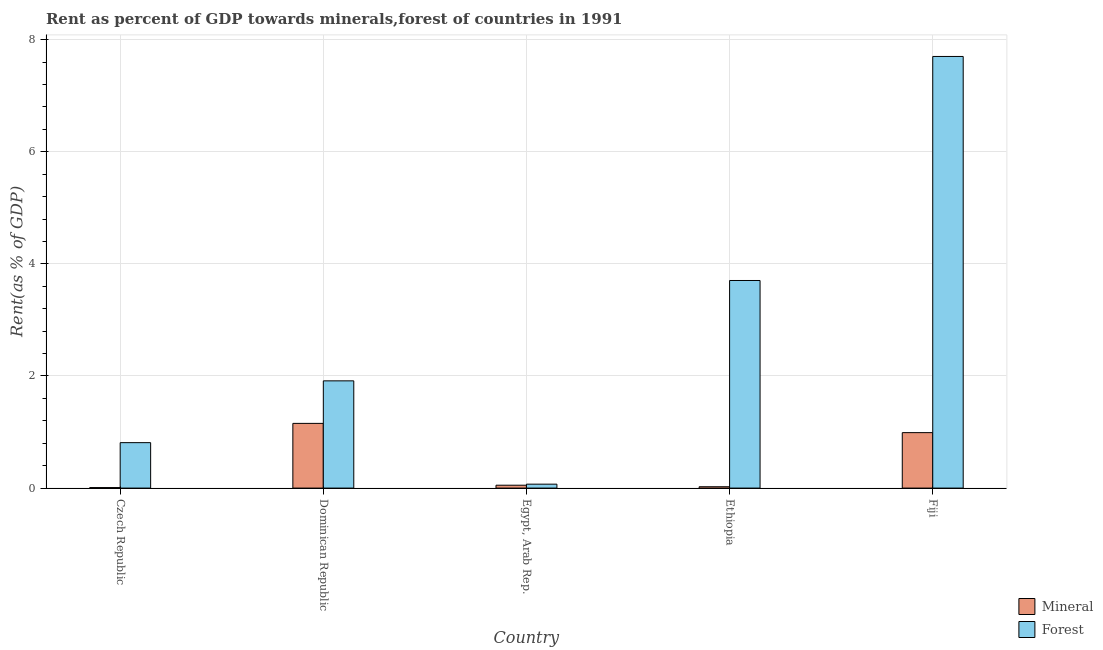Are the number of bars per tick equal to the number of legend labels?
Keep it short and to the point. Yes. Are the number of bars on each tick of the X-axis equal?
Give a very brief answer. Yes. What is the label of the 5th group of bars from the left?
Your answer should be compact. Fiji. What is the mineral rent in Ethiopia?
Your answer should be compact. 0.02. Across all countries, what is the maximum mineral rent?
Offer a terse response. 1.15. Across all countries, what is the minimum forest rent?
Your answer should be very brief. 0.07. In which country was the mineral rent maximum?
Your answer should be compact. Dominican Republic. In which country was the mineral rent minimum?
Ensure brevity in your answer.  Czech Republic. What is the total forest rent in the graph?
Keep it short and to the point. 14.2. What is the difference between the mineral rent in Dominican Republic and that in Egypt, Arab Rep.?
Ensure brevity in your answer.  1.1. What is the difference between the forest rent in Ethiopia and the mineral rent in Dominican Republic?
Offer a terse response. 2.55. What is the average mineral rent per country?
Offer a terse response. 0.45. What is the difference between the mineral rent and forest rent in Egypt, Arab Rep.?
Your answer should be compact. -0.02. What is the ratio of the mineral rent in Czech Republic to that in Egypt, Arab Rep.?
Provide a short and direct response. 0.17. What is the difference between the highest and the second highest mineral rent?
Offer a terse response. 0.17. What is the difference between the highest and the lowest forest rent?
Offer a terse response. 7.63. Is the sum of the forest rent in Czech Republic and Fiji greater than the maximum mineral rent across all countries?
Make the answer very short. Yes. What does the 2nd bar from the left in Egypt, Arab Rep. represents?
Ensure brevity in your answer.  Forest. What does the 2nd bar from the right in Fiji represents?
Offer a very short reply. Mineral. How many bars are there?
Ensure brevity in your answer.  10. What is the difference between two consecutive major ticks on the Y-axis?
Give a very brief answer. 2. Does the graph contain grids?
Offer a terse response. Yes. What is the title of the graph?
Give a very brief answer. Rent as percent of GDP towards minerals,forest of countries in 1991. What is the label or title of the X-axis?
Offer a terse response. Country. What is the label or title of the Y-axis?
Provide a short and direct response. Rent(as % of GDP). What is the Rent(as % of GDP) in Mineral in Czech Republic?
Your answer should be very brief. 0.01. What is the Rent(as % of GDP) of Forest in Czech Republic?
Your answer should be compact. 0.81. What is the Rent(as % of GDP) in Mineral in Dominican Republic?
Provide a succinct answer. 1.15. What is the Rent(as % of GDP) in Forest in Dominican Republic?
Ensure brevity in your answer.  1.91. What is the Rent(as % of GDP) of Mineral in Egypt, Arab Rep.?
Your answer should be compact. 0.05. What is the Rent(as % of GDP) of Forest in Egypt, Arab Rep.?
Your response must be concise. 0.07. What is the Rent(as % of GDP) in Mineral in Ethiopia?
Your answer should be compact. 0.02. What is the Rent(as % of GDP) in Forest in Ethiopia?
Give a very brief answer. 3.7. What is the Rent(as % of GDP) of Mineral in Fiji?
Provide a succinct answer. 0.99. What is the Rent(as % of GDP) in Forest in Fiji?
Give a very brief answer. 7.7. Across all countries, what is the maximum Rent(as % of GDP) of Mineral?
Give a very brief answer. 1.15. Across all countries, what is the maximum Rent(as % of GDP) in Forest?
Keep it short and to the point. 7.7. Across all countries, what is the minimum Rent(as % of GDP) in Mineral?
Provide a succinct answer. 0.01. Across all countries, what is the minimum Rent(as % of GDP) of Forest?
Provide a short and direct response. 0.07. What is the total Rent(as % of GDP) of Mineral in the graph?
Ensure brevity in your answer.  2.23. What is the total Rent(as % of GDP) in Forest in the graph?
Provide a succinct answer. 14.2. What is the difference between the Rent(as % of GDP) in Mineral in Czech Republic and that in Dominican Republic?
Your answer should be very brief. -1.15. What is the difference between the Rent(as % of GDP) in Forest in Czech Republic and that in Dominican Republic?
Offer a terse response. -1.1. What is the difference between the Rent(as % of GDP) in Mineral in Czech Republic and that in Egypt, Arab Rep.?
Your answer should be compact. -0.04. What is the difference between the Rent(as % of GDP) in Forest in Czech Republic and that in Egypt, Arab Rep.?
Your answer should be very brief. 0.74. What is the difference between the Rent(as % of GDP) of Mineral in Czech Republic and that in Ethiopia?
Ensure brevity in your answer.  -0.02. What is the difference between the Rent(as % of GDP) of Forest in Czech Republic and that in Ethiopia?
Your answer should be compact. -2.89. What is the difference between the Rent(as % of GDP) in Mineral in Czech Republic and that in Fiji?
Keep it short and to the point. -0.98. What is the difference between the Rent(as % of GDP) of Forest in Czech Republic and that in Fiji?
Provide a short and direct response. -6.89. What is the difference between the Rent(as % of GDP) of Mineral in Dominican Republic and that in Egypt, Arab Rep.?
Provide a short and direct response. 1.1. What is the difference between the Rent(as % of GDP) in Forest in Dominican Republic and that in Egypt, Arab Rep.?
Give a very brief answer. 1.84. What is the difference between the Rent(as % of GDP) of Mineral in Dominican Republic and that in Ethiopia?
Make the answer very short. 1.13. What is the difference between the Rent(as % of GDP) in Forest in Dominican Republic and that in Ethiopia?
Your answer should be very brief. -1.79. What is the difference between the Rent(as % of GDP) in Mineral in Dominican Republic and that in Fiji?
Your answer should be very brief. 0.17. What is the difference between the Rent(as % of GDP) in Forest in Dominican Republic and that in Fiji?
Ensure brevity in your answer.  -5.79. What is the difference between the Rent(as % of GDP) of Mineral in Egypt, Arab Rep. and that in Ethiopia?
Offer a very short reply. 0.03. What is the difference between the Rent(as % of GDP) in Forest in Egypt, Arab Rep. and that in Ethiopia?
Offer a terse response. -3.63. What is the difference between the Rent(as % of GDP) in Mineral in Egypt, Arab Rep. and that in Fiji?
Provide a succinct answer. -0.94. What is the difference between the Rent(as % of GDP) in Forest in Egypt, Arab Rep. and that in Fiji?
Your response must be concise. -7.63. What is the difference between the Rent(as % of GDP) of Mineral in Ethiopia and that in Fiji?
Give a very brief answer. -0.97. What is the difference between the Rent(as % of GDP) in Forest in Ethiopia and that in Fiji?
Provide a succinct answer. -4. What is the difference between the Rent(as % of GDP) in Mineral in Czech Republic and the Rent(as % of GDP) in Forest in Dominican Republic?
Ensure brevity in your answer.  -1.9. What is the difference between the Rent(as % of GDP) of Mineral in Czech Republic and the Rent(as % of GDP) of Forest in Egypt, Arab Rep.?
Offer a terse response. -0.06. What is the difference between the Rent(as % of GDP) of Mineral in Czech Republic and the Rent(as % of GDP) of Forest in Ethiopia?
Your response must be concise. -3.7. What is the difference between the Rent(as % of GDP) of Mineral in Czech Republic and the Rent(as % of GDP) of Forest in Fiji?
Give a very brief answer. -7.69. What is the difference between the Rent(as % of GDP) in Mineral in Dominican Republic and the Rent(as % of GDP) in Forest in Egypt, Arab Rep.?
Your answer should be very brief. 1.08. What is the difference between the Rent(as % of GDP) of Mineral in Dominican Republic and the Rent(as % of GDP) of Forest in Ethiopia?
Ensure brevity in your answer.  -2.55. What is the difference between the Rent(as % of GDP) in Mineral in Dominican Republic and the Rent(as % of GDP) in Forest in Fiji?
Give a very brief answer. -6.55. What is the difference between the Rent(as % of GDP) of Mineral in Egypt, Arab Rep. and the Rent(as % of GDP) of Forest in Ethiopia?
Your answer should be compact. -3.65. What is the difference between the Rent(as % of GDP) of Mineral in Egypt, Arab Rep. and the Rent(as % of GDP) of Forest in Fiji?
Offer a very short reply. -7.65. What is the difference between the Rent(as % of GDP) in Mineral in Ethiopia and the Rent(as % of GDP) in Forest in Fiji?
Provide a short and direct response. -7.68. What is the average Rent(as % of GDP) of Mineral per country?
Ensure brevity in your answer.  0.45. What is the average Rent(as % of GDP) of Forest per country?
Offer a terse response. 2.84. What is the difference between the Rent(as % of GDP) of Mineral and Rent(as % of GDP) of Forest in Czech Republic?
Your answer should be compact. -0.8. What is the difference between the Rent(as % of GDP) of Mineral and Rent(as % of GDP) of Forest in Dominican Republic?
Make the answer very short. -0.76. What is the difference between the Rent(as % of GDP) in Mineral and Rent(as % of GDP) in Forest in Egypt, Arab Rep.?
Your answer should be very brief. -0.02. What is the difference between the Rent(as % of GDP) of Mineral and Rent(as % of GDP) of Forest in Ethiopia?
Ensure brevity in your answer.  -3.68. What is the difference between the Rent(as % of GDP) in Mineral and Rent(as % of GDP) in Forest in Fiji?
Provide a succinct answer. -6.71. What is the ratio of the Rent(as % of GDP) of Mineral in Czech Republic to that in Dominican Republic?
Your answer should be compact. 0.01. What is the ratio of the Rent(as % of GDP) of Forest in Czech Republic to that in Dominican Republic?
Your response must be concise. 0.42. What is the ratio of the Rent(as % of GDP) of Mineral in Czech Republic to that in Egypt, Arab Rep.?
Your response must be concise. 0.17. What is the ratio of the Rent(as % of GDP) of Forest in Czech Republic to that in Egypt, Arab Rep.?
Your response must be concise. 11.57. What is the ratio of the Rent(as % of GDP) in Mineral in Czech Republic to that in Ethiopia?
Your answer should be compact. 0.37. What is the ratio of the Rent(as % of GDP) of Forest in Czech Republic to that in Ethiopia?
Provide a short and direct response. 0.22. What is the ratio of the Rent(as % of GDP) in Mineral in Czech Republic to that in Fiji?
Provide a short and direct response. 0.01. What is the ratio of the Rent(as % of GDP) of Forest in Czech Republic to that in Fiji?
Provide a short and direct response. 0.11. What is the ratio of the Rent(as % of GDP) in Mineral in Dominican Republic to that in Egypt, Arab Rep.?
Your response must be concise. 22.42. What is the ratio of the Rent(as % of GDP) in Forest in Dominican Republic to that in Egypt, Arab Rep.?
Ensure brevity in your answer.  27.29. What is the ratio of the Rent(as % of GDP) of Mineral in Dominican Republic to that in Ethiopia?
Offer a very short reply. 48.22. What is the ratio of the Rent(as % of GDP) of Forest in Dominican Republic to that in Ethiopia?
Keep it short and to the point. 0.52. What is the ratio of the Rent(as % of GDP) in Mineral in Dominican Republic to that in Fiji?
Offer a terse response. 1.17. What is the ratio of the Rent(as % of GDP) of Forest in Dominican Republic to that in Fiji?
Keep it short and to the point. 0.25. What is the ratio of the Rent(as % of GDP) in Mineral in Egypt, Arab Rep. to that in Ethiopia?
Make the answer very short. 2.15. What is the ratio of the Rent(as % of GDP) in Forest in Egypt, Arab Rep. to that in Ethiopia?
Offer a terse response. 0.02. What is the ratio of the Rent(as % of GDP) of Mineral in Egypt, Arab Rep. to that in Fiji?
Your response must be concise. 0.05. What is the ratio of the Rent(as % of GDP) in Forest in Egypt, Arab Rep. to that in Fiji?
Ensure brevity in your answer.  0.01. What is the ratio of the Rent(as % of GDP) in Mineral in Ethiopia to that in Fiji?
Provide a succinct answer. 0.02. What is the ratio of the Rent(as % of GDP) of Forest in Ethiopia to that in Fiji?
Give a very brief answer. 0.48. What is the difference between the highest and the second highest Rent(as % of GDP) of Mineral?
Your response must be concise. 0.17. What is the difference between the highest and the second highest Rent(as % of GDP) of Forest?
Keep it short and to the point. 4. What is the difference between the highest and the lowest Rent(as % of GDP) of Mineral?
Provide a short and direct response. 1.15. What is the difference between the highest and the lowest Rent(as % of GDP) of Forest?
Offer a terse response. 7.63. 